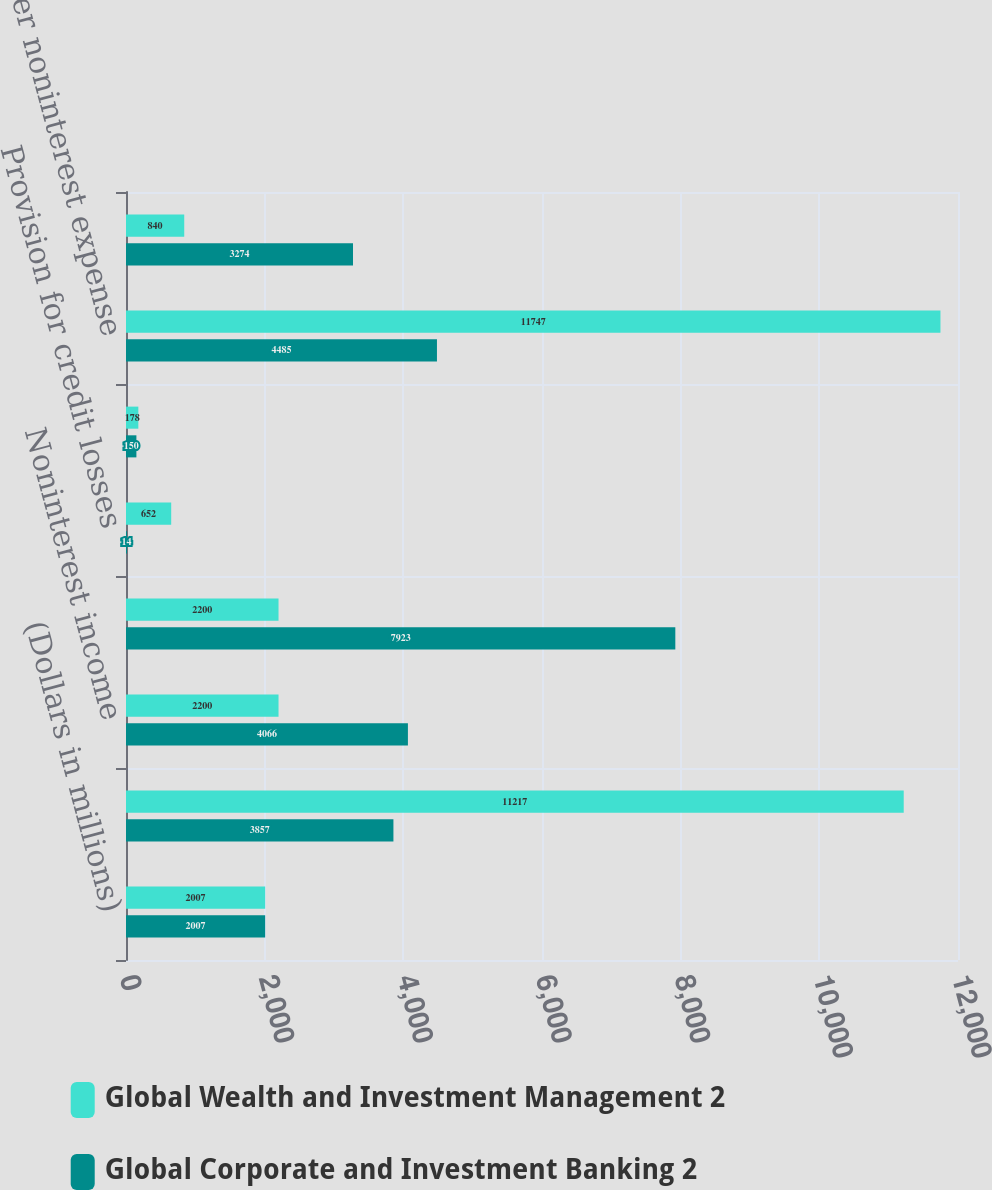Convert chart. <chart><loc_0><loc_0><loc_500><loc_500><stacked_bar_chart><ecel><fcel>(Dollars in millions)<fcel>Net interest income (4)<fcel>Noninterest income<fcel>Total revenue net of interest<fcel>Provision for credit losses<fcel>Amortization of intangibles<fcel>Other noninterest expense<fcel>Income before income taxes<nl><fcel>Global Wealth and Investment Management 2<fcel>2007<fcel>11217<fcel>2200<fcel>2200<fcel>652<fcel>178<fcel>11747<fcel>840<nl><fcel>Global Corporate and Investment Banking 2<fcel>2007<fcel>3857<fcel>4066<fcel>7923<fcel>14<fcel>150<fcel>4485<fcel>3274<nl></chart> 